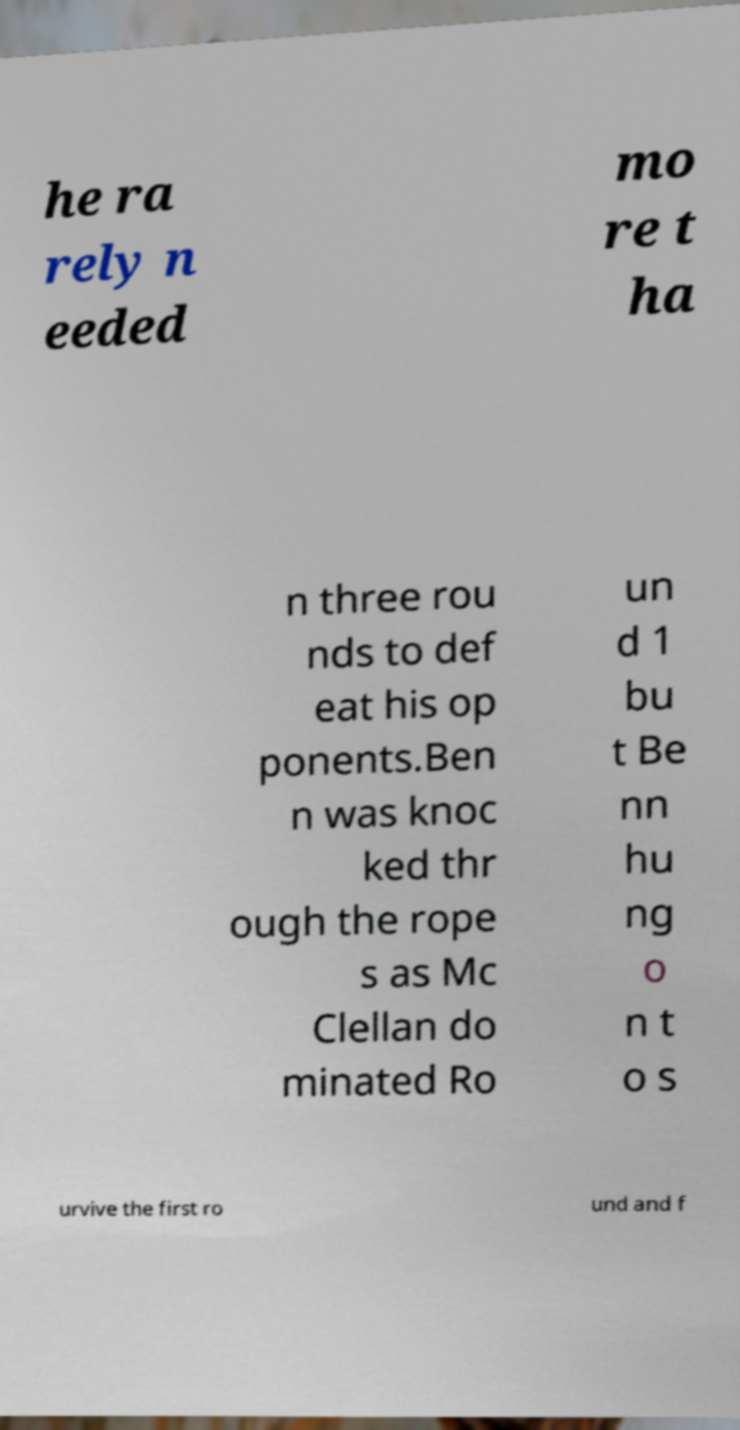For documentation purposes, I need the text within this image transcribed. Could you provide that? he ra rely n eeded mo re t ha n three rou nds to def eat his op ponents.Ben n was knoc ked thr ough the rope s as Mc Clellan do minated Ro un d 1 bu t Be nn hu ng o n t o s urvive the first ro und and f 